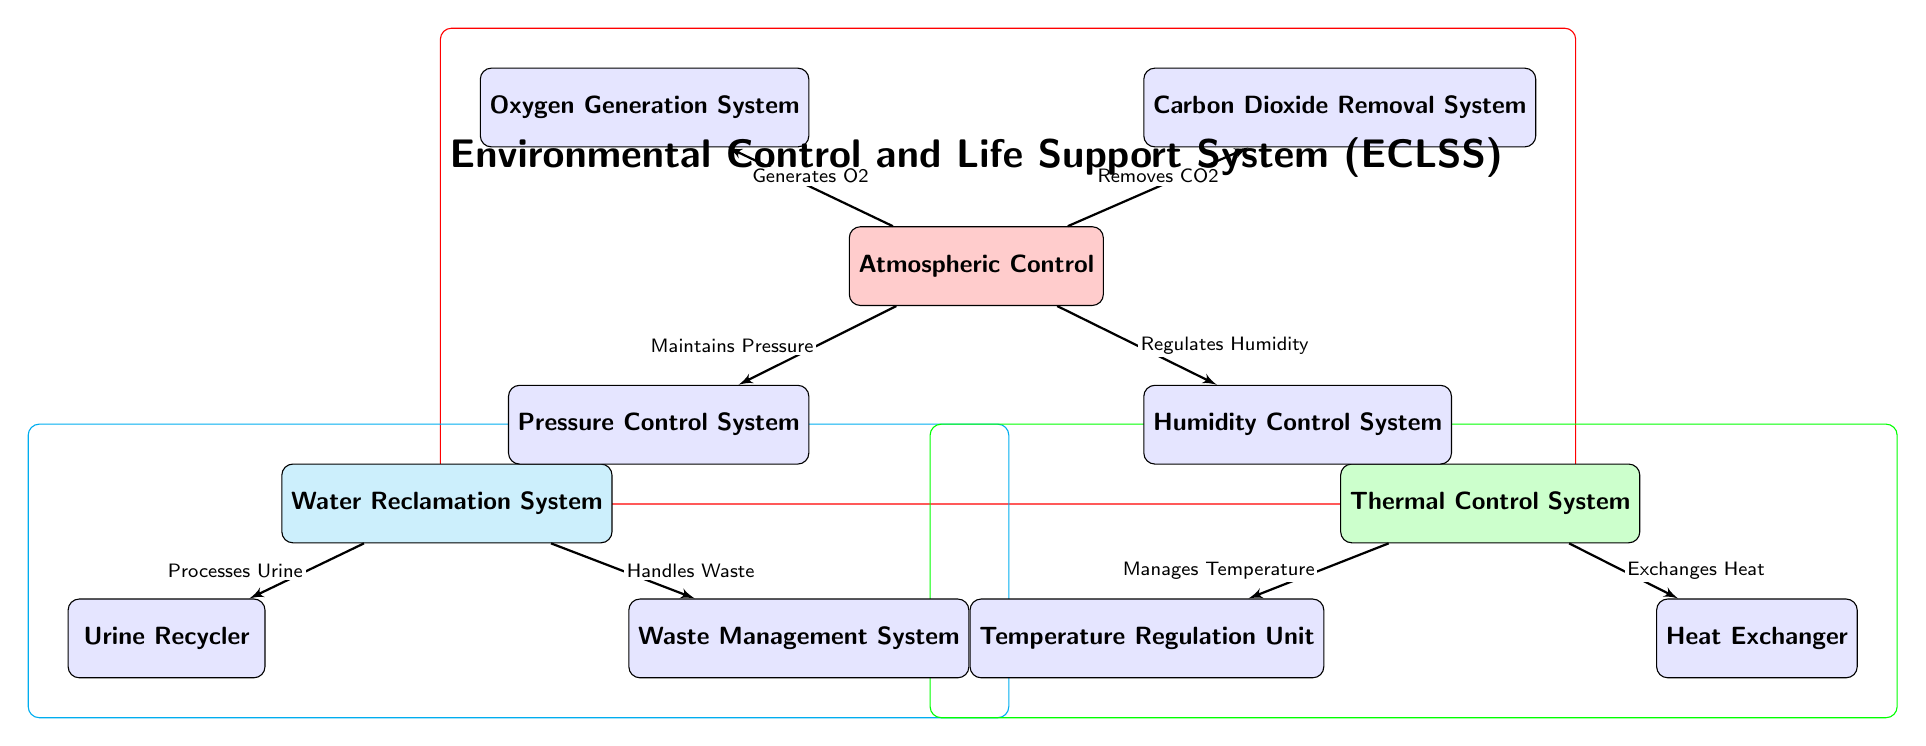What is the main system shown in the diagram? The diagram illustrates the Environmental Control and Life Support System (ECLSS) as the main system, clearly indicated at the top.
Answer: Environmental Control and Life Support System (ECLSS) How many subsystems are associated with the Atmospheric Control? The Atmospheric Control has four subsystems as shown: Oxygen Generation System, Carbon Dioxide Removal System, Pressure Control System, and Humidity Control System.
Answer: Four What process does the Oxygen Generation System perform? The diagram indicates that the Oxygen Generation System generates oxygen, which is a critical activity within the Atmospheric Control.
Answer: Generates O2 Which subsystem handles the recycling of urine? The diagram specifies that the Urine Recycler processes urine as part of the Water Reclamation System.
Answer: Urine Recycler What connection does the Thermal Control System have? The Thermal Control System manages temperature and exchanges heat, as indicated by the arrows leading to the Temperature Regulation Unit and Heat Exchanger.
Answer: Manages Temperature and Exchanges Heat What is the relationship between the Water Reclamation System and the Waste Management System? The diagram demonstrates that the Water Reclamation System handles waste through a direct connection labeled "Handles Waste," indicating collaboration in waste management.
Answer: Handles Waste How many main systems are illustrated in the diagram? The diagram has three main systems depicted: Atmospheric Control, Water Reclamation System, and Thermal Control System.
Answer: Three What subsystem is responsible for maintaining pressure? The Pressure Control System is identified in the diagram as the subsystem responsible for maintaining pressure within the Atmospheric Control.
Answer: Pressure Control System What color represents the Atmosphere Control system in the diagram? The Atmospheric Control system is visually represented in red, as seen in the color filling around that subsystem in the diagram.
Answer: Red 